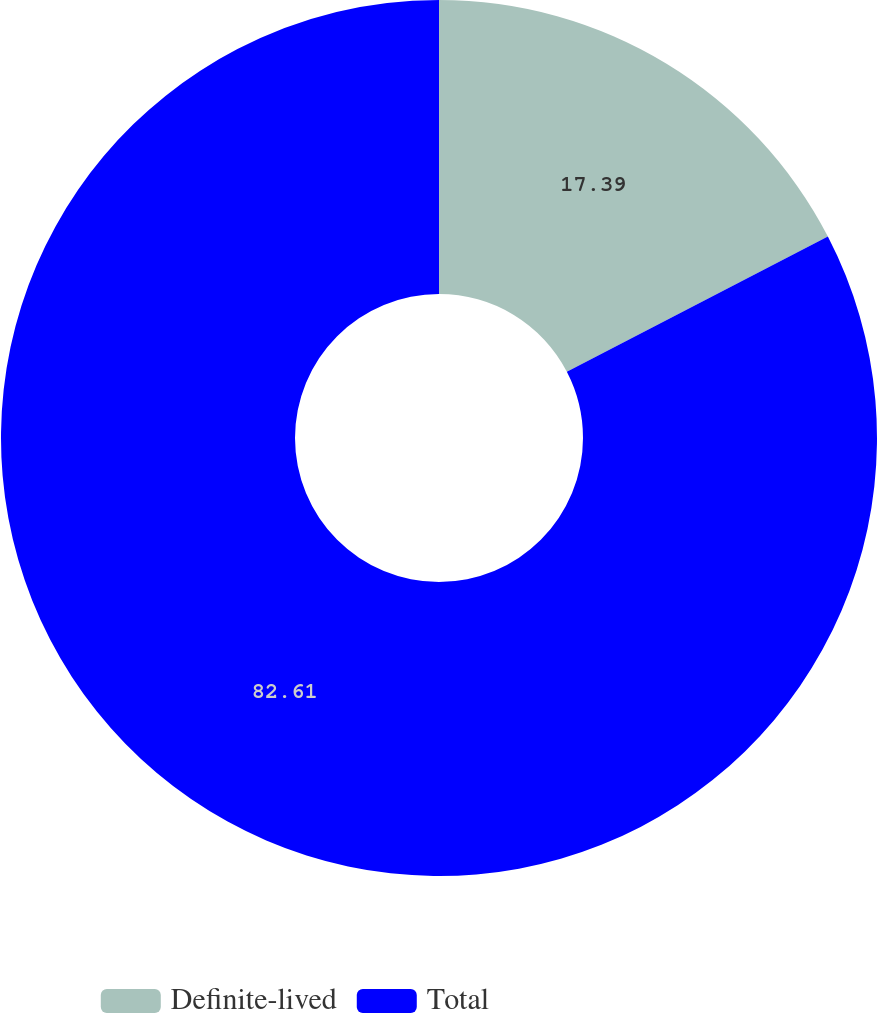<chart> <loc_0><loc_0><loc_500><loc_500><pie_chart><fcel>Definite-lived<fcel>Total<nl><fcel>17.39%<fcel>82.61%<nl></chart> 